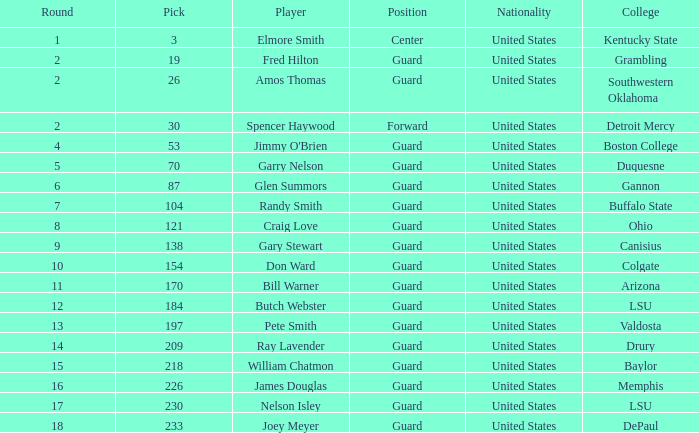WHAT IS THE TOTAL PICK FOR BOSTON COLLEGE? 1.0. 